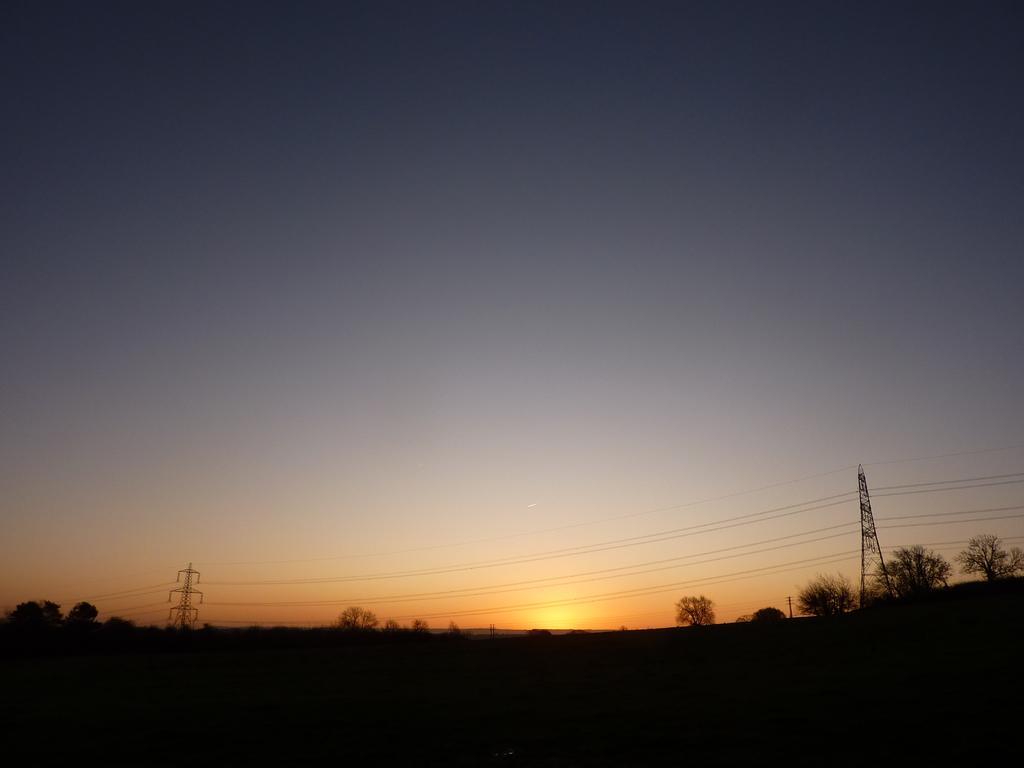In one or two sentences, can you explain what this image depicts? In this image I can see few towers, wires and number of trees on the bottom side. I can also see the sky and the sun in the background. 